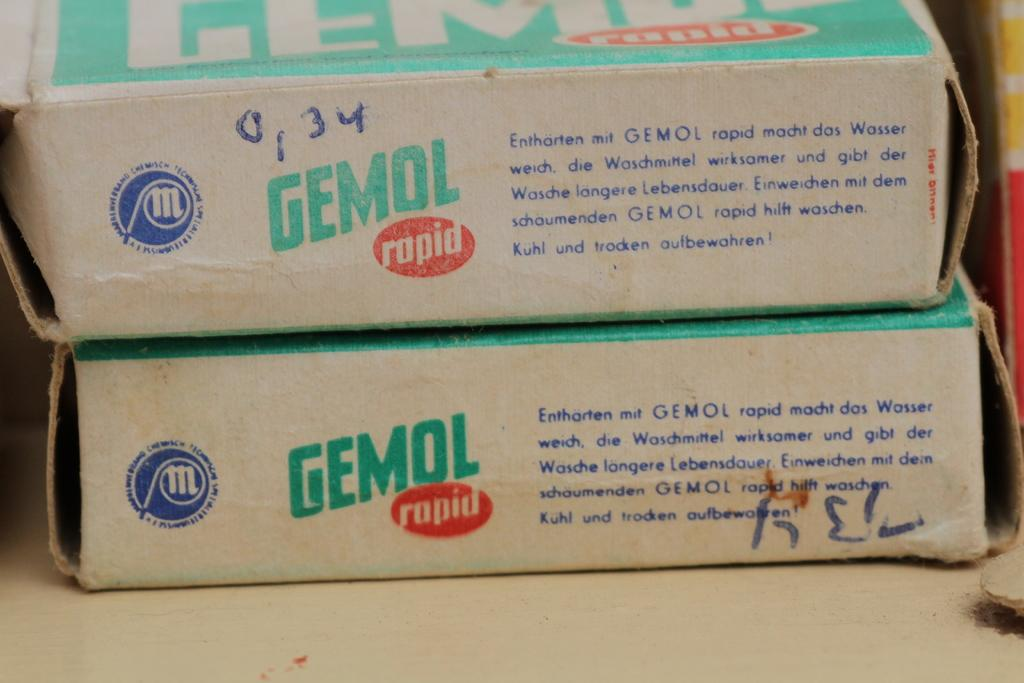<image>
Offer a succinct explanation of the picture presented. Two old, frayed at the edges boxes of GEMOL rapid 